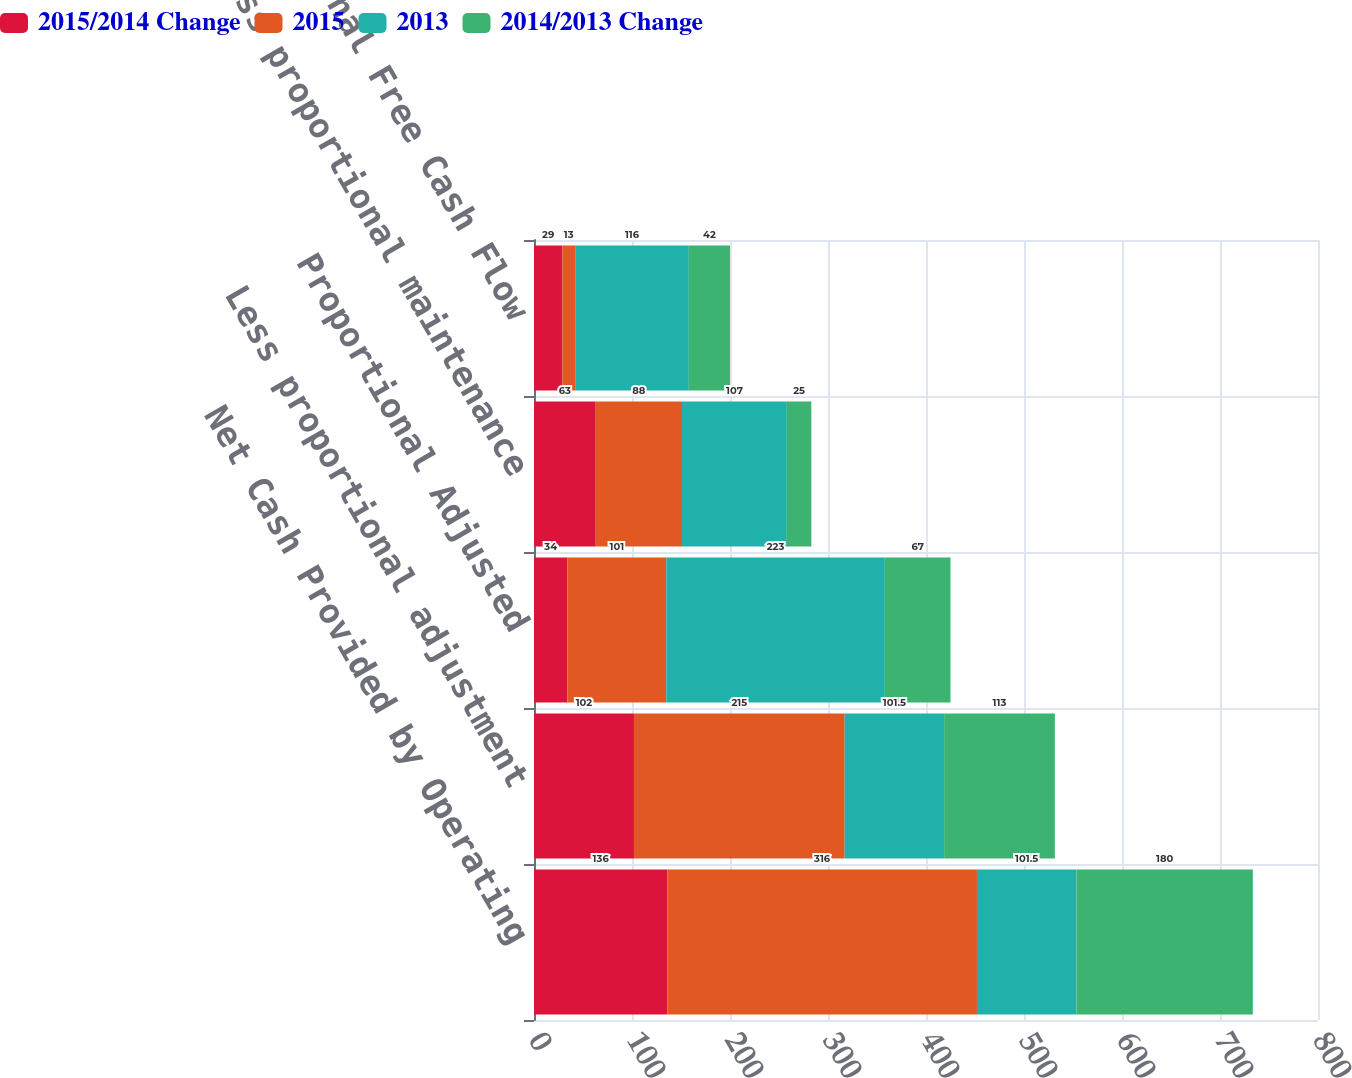<chart> <loc_0><loc_0><loc_500><loc_500><stacked_bar_chart><ecel><fcel>Net Cash Provided by Operating<fcel>Less proportional adjustment<fcel>Proportional Adjusted<fcel>Less proportional maintenance<fcel>Proportional Free Cash Flow<nl><fcel>2015/2014 Change<fcel>136<fcel>102<fcel>34<fcel>63<fcel>29<nl><fcel>2015<fcel>316<fcel>215<fcel>101<fcel>88<fcel>13<nl><fcel>2013<fcel>101.5<fcel>101.5<fcel>223<fcel>107<fcel>116<nl><fcel>2014/2013 Change<fcel>180<fcel>113<fcel>67<fcel>25<fcel>42<nl></chart> 